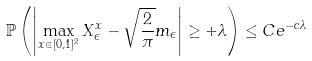Convert formula to latex. <formula><loc_0><loc_0><loc_500><loc_500>\mathbb { P } \left ( \left | \max _ { x \in [ 0 , 1 ] ^ { 2 } } X _ { \epsilon } ^ { x } - \sqrt { \frac { 2 } { \pi } } m _ { \epsilon } \right | \geq + \lambda \right ) \leq C e ^ { - c \lambda }</formula> 